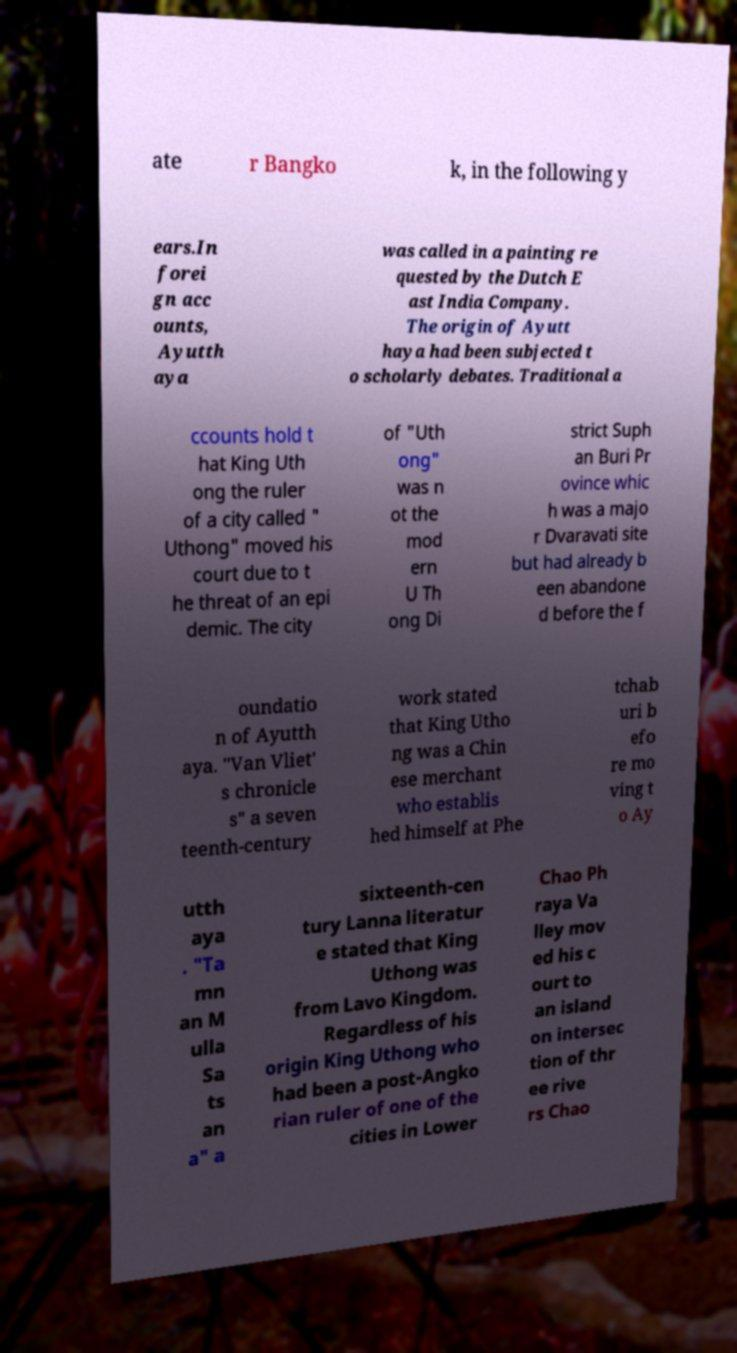There's text embedded in this image that I need extracted. Can you transcribe it verbatim? ate r Bangko k, in the following y ears.In forei gn acc ounts, Ayutth aya was called in a painting re quested by the Dutch E ast India Company. The origin of Ayutt haya had been subjected t o scholarly debates. Traditional a ccounts hold t hat King Uth ong the ruler of a city called " Uthong" moved his court due to t he threat of an epi demic. The city of "Uth ong" was n ot the mod ern U Th ong Di strict Suph an Buri Pr ovince whic h was a majo r Dvaravati site but had already b een abandone d before the f oundatio n of Ayutth aya. "Van Vliet' s chronicle s" a seven teenth-century work stated that King Utho ng was a Chin ese merchant who establis hed himself at Phe tchab uri b efo re mo ving t o Ay utth aya . "Ta mn an M ulla Sa ts an a" a sixteenth-cen tury Lanna literatur e stated that King Uthong was from Lavo Kingdom. Regardless of his origin King Uthong who had been a post-Angko rian ruler of one of the cities in Lower Chao Ph raya Va lley mov ed his c ourt to an island on intersec tion of thr ee rive rs Chao 